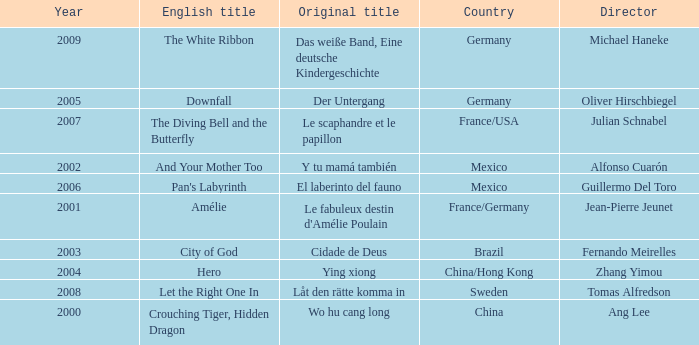Name the title of jean-pierre jeunet Amélie. 